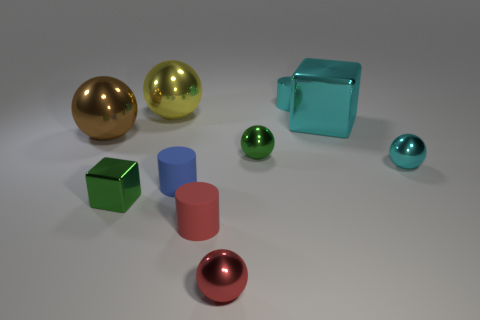There is a shiny cube that is the same color as the metallic cylinder; what size is it?
Your answer should be compact. Large. Does the green metal sphere have the same size as the green cube?
Your answer should be very brief. Yes. There is a shiny object that is both on the left side of the yellow ball and in front of the tiny cyan ball; what is its color?
Provide a short and direct response. Green. What is the shape of the brown thing that is the same material as the yellow sphere?
Ensure brevity in your answer.  Sphere. How many spheres are on the left side of the green block and right of the green block?
Offer a terse response. 0. Are there any large shiny cubes in front of the small cyan shiny cylinder?
Give a very brief answer. Yes. There is a tiny cyan shiny object that is behind the large cube; does it have the same shape as the matte object on the right side of the small blue rubber thing?
Keep it short and to the point. Yes. How many things are either small purple rubber objects or small balls that are right of the metallic cylinder?
Your answer should be very brief. 1. How many other objects are the same shape as the yellow metal thing?
Give a very brief answer. 4. Are the object that is in front of the red matte object and the large brown thing made of the same material?
Your answer should be very brief. Yes. 